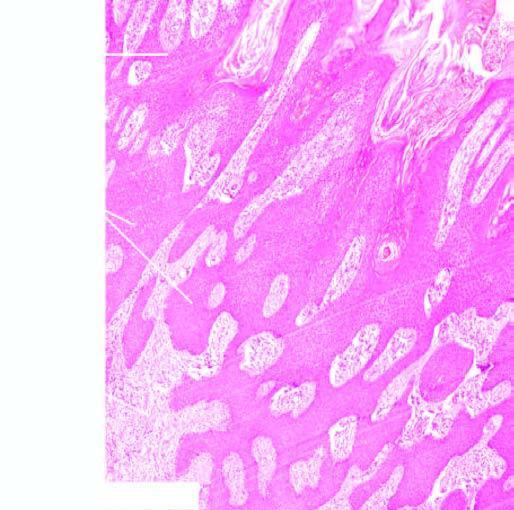what does the epidermis show in the number of layers of the squamous epithelium?
Answer the question using a single word or phrase. An increase 